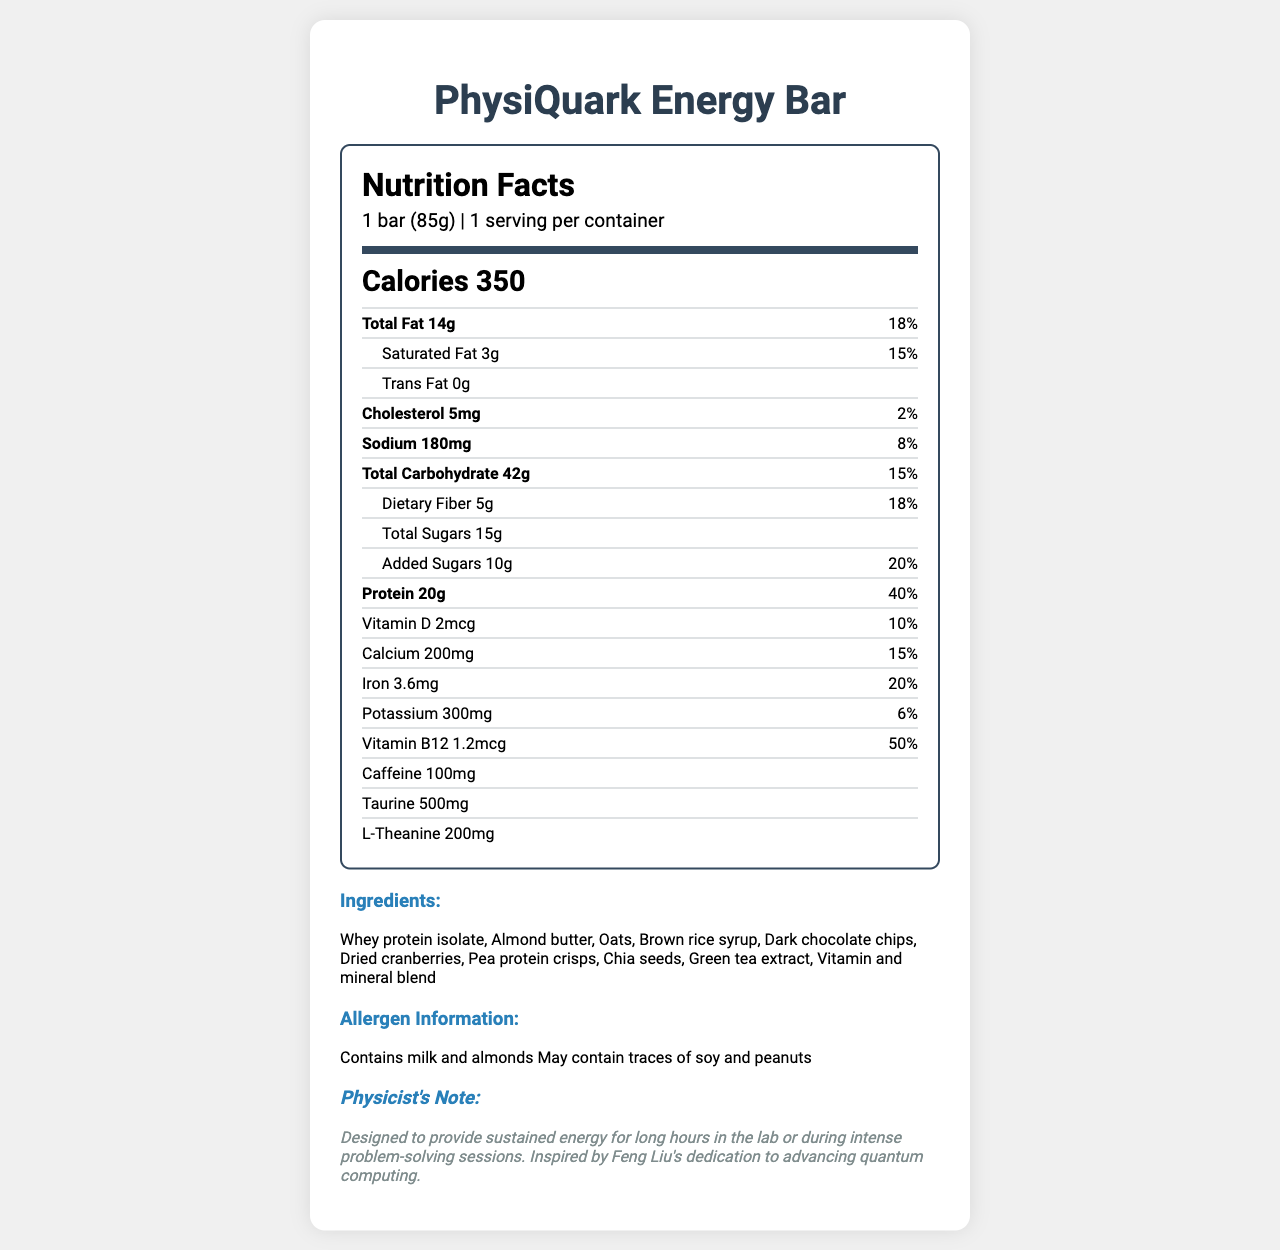what is the serving size of the PhysiQuark Energy Bar? The serving size is stated as "1 bar (85g)" under the section "serving info".
Answer: 1 bar (85g) how many calories are in one serving of the PhysiQuark Energy Bar? The calorie count is prominently displayed as "Calories 350" in the document.
Answer: 350 what percentage of the daily value of protein does the bar provide? The protein content is listed as "20g" with a daily value of "40%" in the nutritional information.
Answer: 40% how much caffeine is included in the PhysiQuark Energy Bar? The amount of caffeine listed is "100mg" under the section for additional ingredients.
Answer: 100mg list three main ingredients in the PhysiQuark Energy Bar. The ingredients section lists "Whey protein isolate, Almond butter, Oats" among other components.
Answer: Whey protein isolate, Almond butter, Oats What is the percentage of daily value of iron provided by the bar? A. 10% B. 15% C. 20% D. 25% The iron content is listed as "3.6mg" with a daily value of "20%" in the nutritional information.
Answer: C. 20% What nutrients in the bar have daily values of 15%? A. Total Fat & Calcium B. Saturated Fat & Sodium C. Calcium & Saturated Fat Both "Saturated Fat" and "Calcium" have daily values of "15%" according to the nutritional information.
Answer: C. Calcium & Saturated Fat is the PhysiQuark Energy Bar suitable for someone with a peanut allergy? The allergen information states "May contain traces of soy and peanuts", indicating it is not safe for someone with a peanut allergy.
Answer: No summarize the main purpose of the PhysiQuark Energy Bar. The physicist's note mentions the bar is intended to provide sustained energy for long hours in the lab, inspired by Feng Liu's dedication to advancing quantum computing.
Answer: The PhysiQuark Energy Bar is designed to provide sustained energy for physicists working long hours in the lab or during intense problem-solving sessions. who inspired the creation of the PhysiQuark Energy Bar? The document notes it was inspired by Feng Liu's dedication to advancing quantum computing, but it does not specify who exactly created the bar.
Answer: Not enough information 